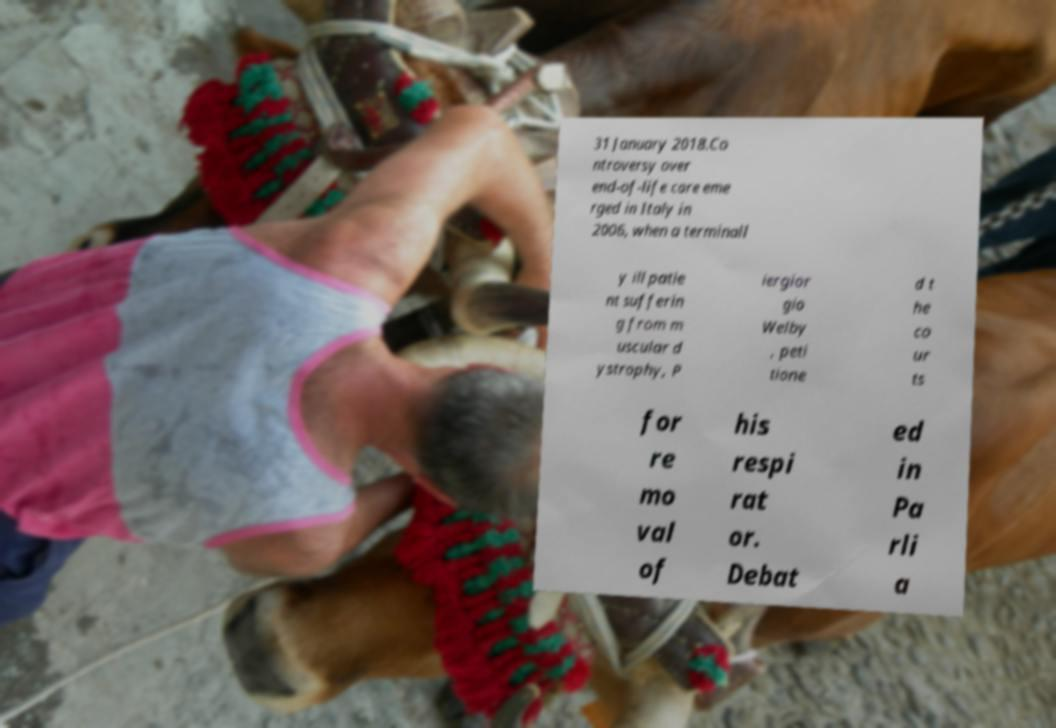For documentation purposes, I need the text within this image transcribed. Could you provide that? 31 January 2018.Co ntroversy over end-of-life care eme rged in Italy in 2006, when a terminall y ill patie nt sufferin g from m uscular d ystrophy, P iergior gio Welby , peti tione d t he co ur ts for re mo val of his respi rat or. Debat ed in Pa rli a 